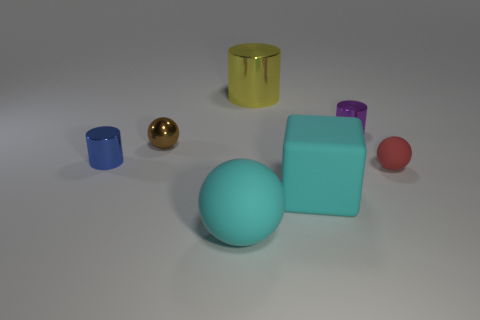Is there a big green object made of the same material as the cyan block?
Keep it short and to the point. No. What is the color of the tiny object that is both in front of the tiny brown thing and left of the yellow object?
Your answer should be very brief. Blue. There is a ball that is behind the tiny red matte thing; what material is it?
Ensure brevity in your answer.  Metal. Is there another object of the same shape as the yellow object?
Ensure brevity in your answer.  Yes. What number of other objects are the same shape as the big yellow metallic object?
Provide a succinct answer. 2. Does the big yellow metal thing have the same shape as the tiny metal object that is right of the block?
Provide a short and direct response. Yes. What is the material of the red thing that is the same shape as the brown object?
Make the answer very short. Rubber. What number of tiny objects are either red rubber spheres or metallic things?
Ensure brevity in your answer.  4. Is the number of cyan matte things that are on the left side of the small brown shiny ball less than the number of tiny objects that are behind the small blue thing?
Offer a very short reply. Yes. How many things are blocks or matte things?
Give a very brief answer. 3. 